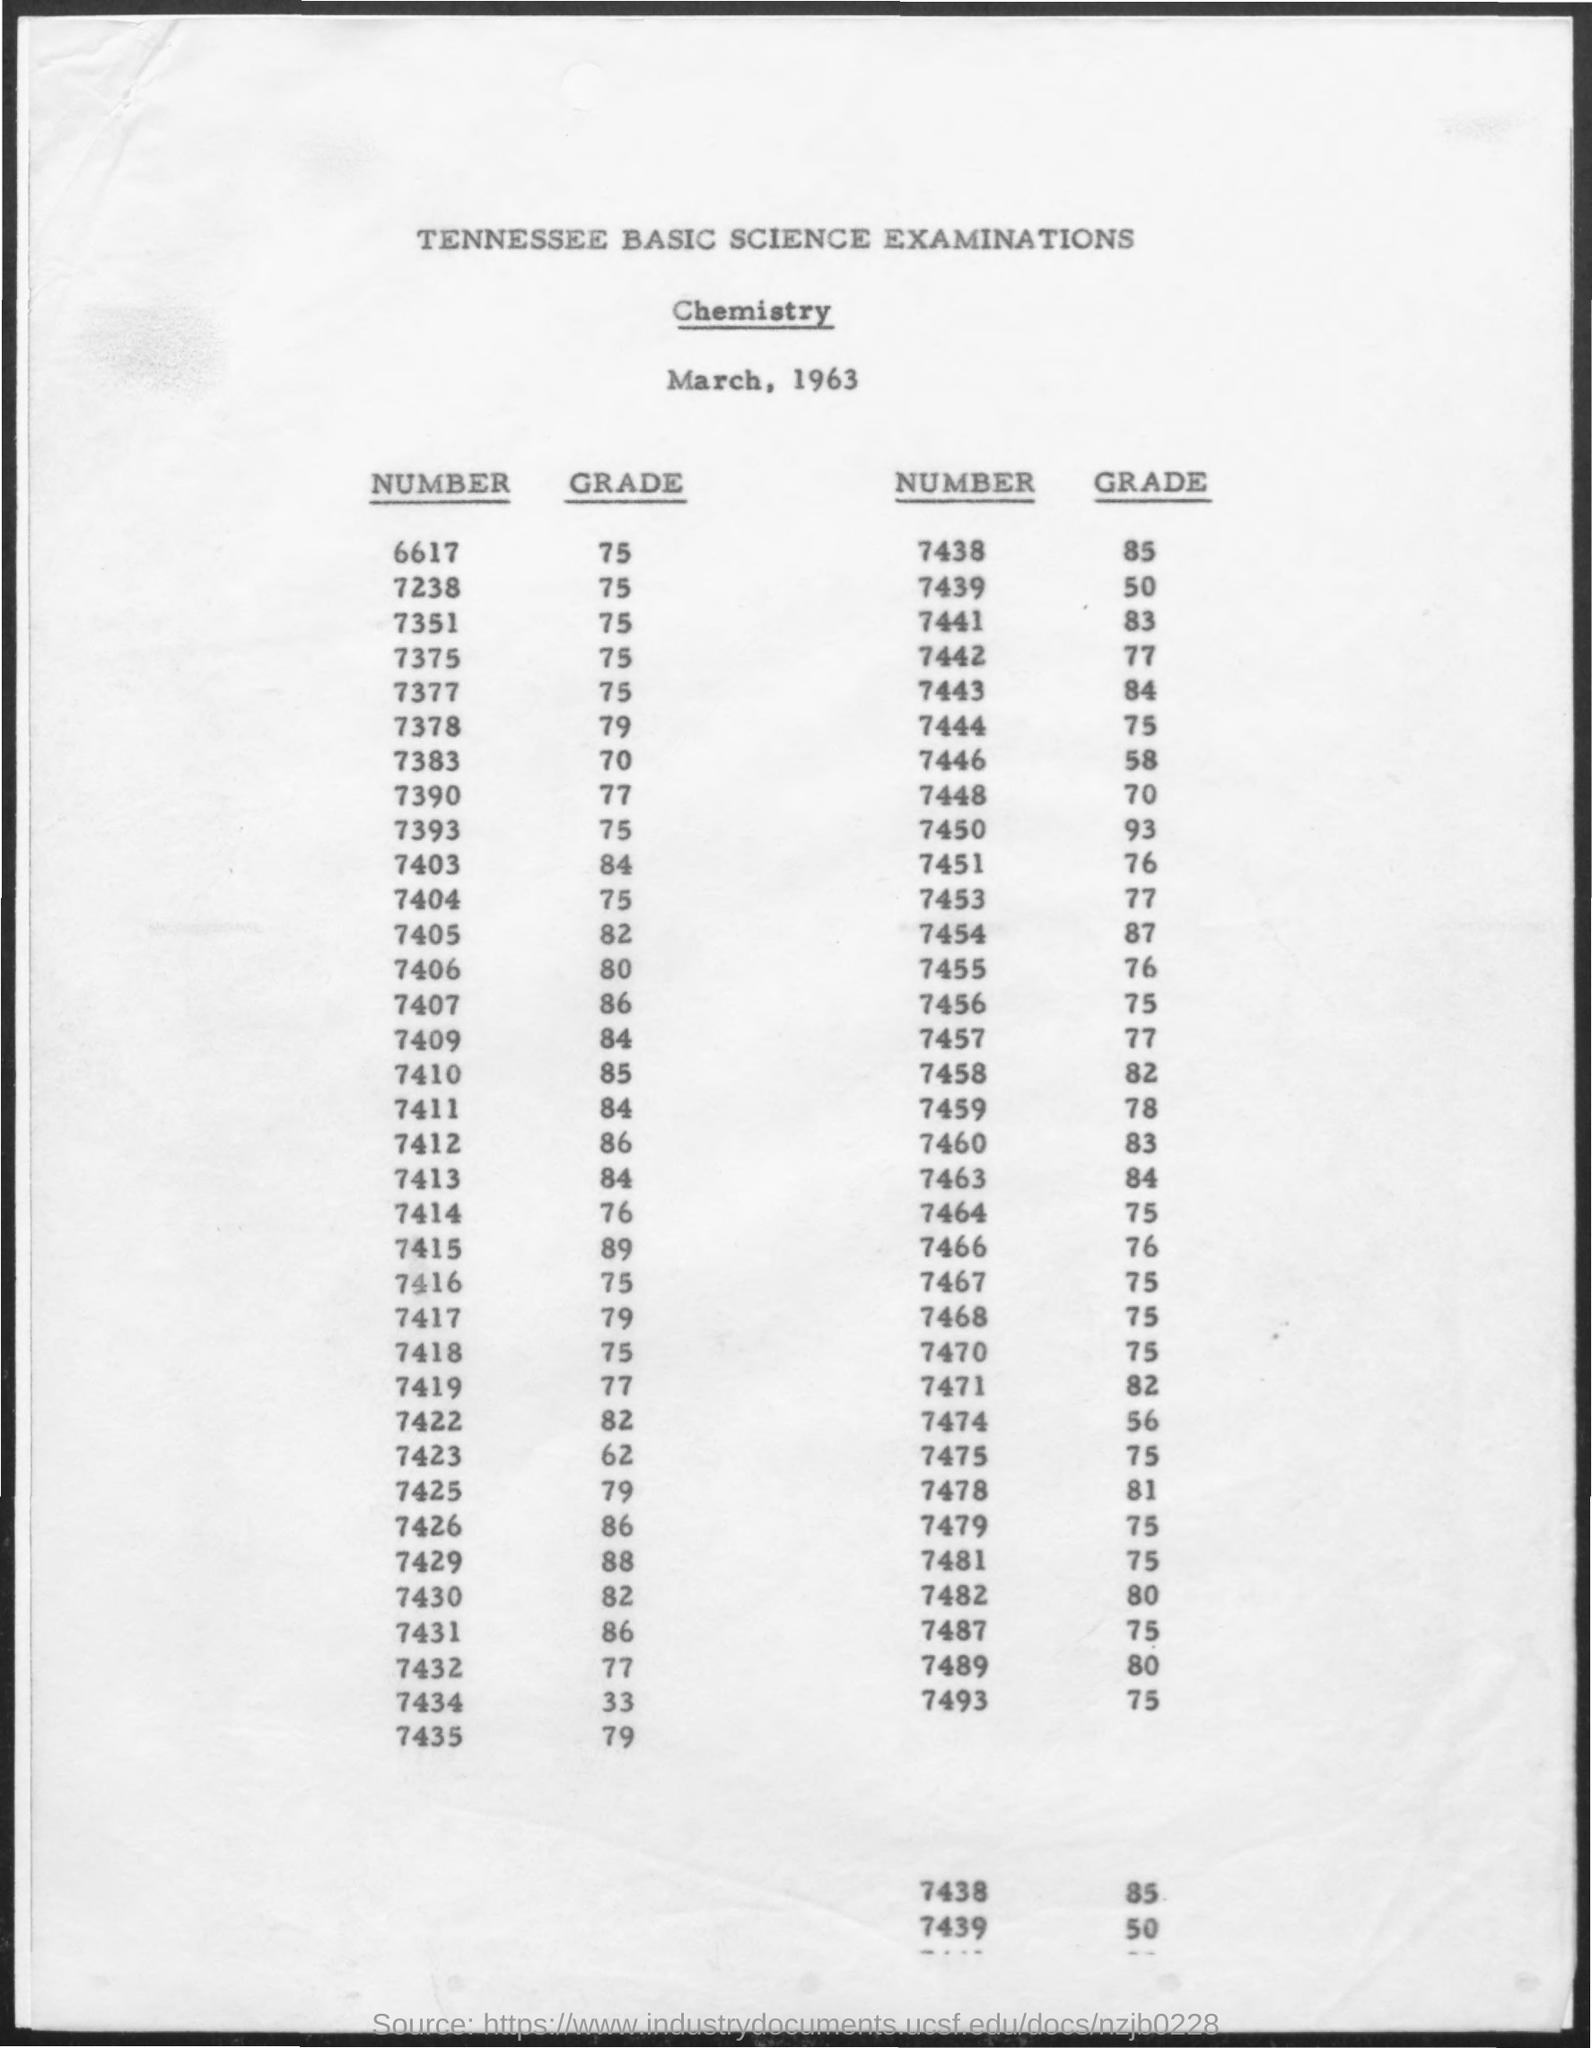Draw attention to some important aspects in this diagram. The grade for the number 7463 is not specified. It is also not clear what the context or purpose is for asking about the grade of this specific number. Additionally, the phrase "84.." is not clear and does not convey any information. The grade for the number 7393 is not specified. Additionally, the number 75 is not included in the question. The number 7435 is a grade. The number 6617 is a grade. The grade for the number 6617 is 75. The grade for the number 7481 is 75. 